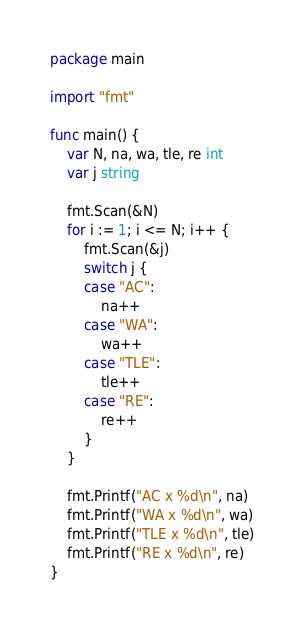Convert code to text. <code><loc_0><loc_0><loc_500><loc_500><_Go_>package main

import "fmt"

func main() {
	var N, na, wa, tle, re int
	var j string

	fmt.Scan(&N)
	for i := 1; i <= N; i++ {
		fmt.Scan(&j)
		switch j {
		case "AC":
			na++
		case "WA":
			wa++
		case "TLE":
			tle++
		case "RE":
			re++
		}
	}

	fmt.Printf("AC x %d\n", na)
	fmt.Printf("WA x %d\n", wa)
	fmt.Printf("TLE x %d\n", tle)
	fmt.Printf("RE x %d\n", re)
}
</code> 